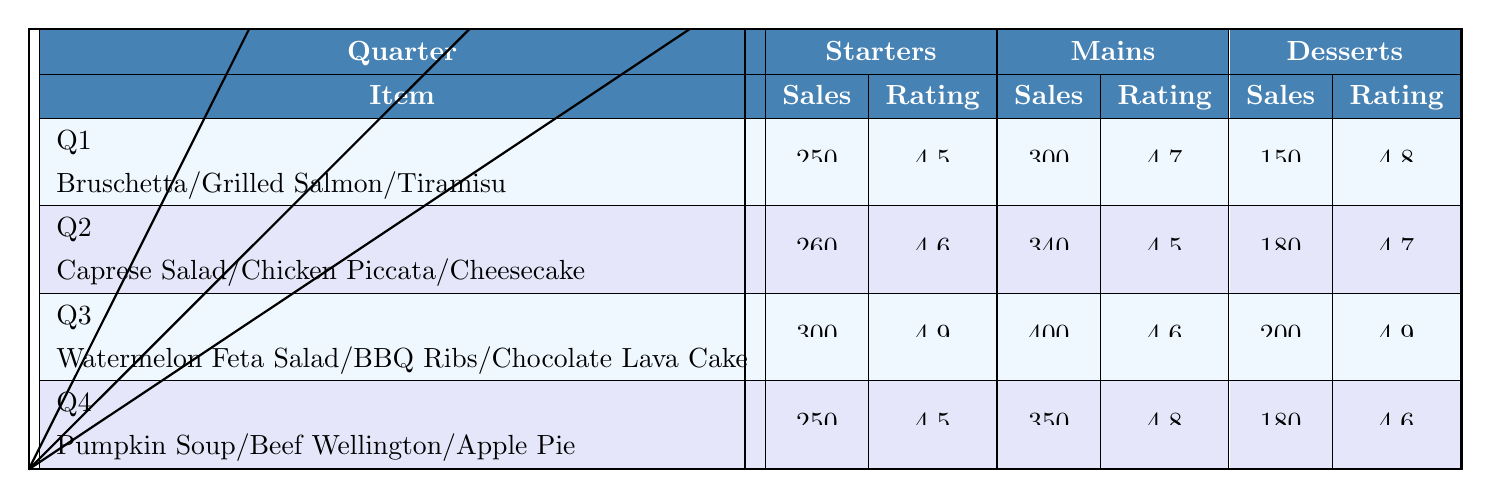What are the sales figures for the Grilled Salmon in Q1? According to the table, under Q1 in the Mains category, the sales for the Grilled Salmon are listed as 300.
Answer: 300 Which dessert had the highest rating in Q3? In Q3 under Desserts, the Chocolate Lava Cake has a rating of 4.9, which is higher than the Peach Cobbler's rating of 4.8.
Answer: Chocolate Lava Cake What is the average customer rating for Starters across all quarters? The ratings for Starters in each quarter are: Q1 - 4.5, Q2 - 4.6, Q3 - 4.9, Q4 - 4.5. To find the average, we sum these ratings (4.5 + 4.6 + 4.9 + 4.5 = 18.5) and divide by the number of quarters (18.5 / 4 = 4.625).
Answer: 4.625 Did the Fried Calamari receive a higher rating than the Stuffed Mushrooms? The Fried Calamari has a rating of 4.4, while the Stuffed Mushrooms have a rating of 4.0. Since 4.4 is greater than 4.0, it means the Fried Calamari received a higher rating.
Answer: Yes What was the total sales for Desserts in Q2 compared to Q3? The total sales for Desserts in Q2 is 180 (for Cheesecake) + 120 (for Fruit Tart) = 300. In Q3, the total for Desserts is 200 (for Chocolate Lava Cake) + 160 (for Peach Cobbler) = 360. Since 300 (Q2) is less than 360 (Q3), Q3 had higher sales.
Answer: Q3 had higher sales Which Starter had the lowest sales in Q4? In Q4 under Starters, the Pumpkin Soup has sales of 250 and the Spinach Artichoke Dip has 240. Since 240 is less than 250, Spinach Artichoke Dip has the lowest sales in Q4.
Answer: Spinach Artichoke Dip What is the difference in sales between the Chicken Piccata and the BBQ Ribs? The sales for Chicken Piccata in Q2 is 340, and the sales for BBQ Ribs in Q3 is 400. To find the difference, we subtract 340 from 400 (400 - 340 = 60).
Answer: 60 How many desserts had a rating of 4.5 or higher in Q4? The ratings in Q4 for desserts are 4.6 (Apple Pie) and 4.5 (Pecan Pie). Both ratings are 4.5 or higher, leading to a total of 2 desserts.
Answer: 2 What is the best-selling Main dish of the year based on the Q3 data? The BBQ Ribs in Q3 had the highest sales at 400 compared to the other mains in Q3. Therefore, they are the best-selling Main dish of the year based on Q3 data.
Answer: BBQ Ribs Which quarter had the lowest total sales for Desserts? The total sales for Desserts in each quarter are Q1 - 150 (Tiramisu) + 100 (Lavender Ice Cream) = 250, Q2 - 180 (Cheesecake) + 120 (Fruit Tart) = 300, Q3 - 160 (Peach Cobbler) + 200 (Chocolate Lava Cake) = 360, Q4 - 180 (Apple Pie) + 130 (Pecan Pie) = 310. Since 250 is the lowest, Q1 had the lowest total sales for Desserts.
Answer: Q1 